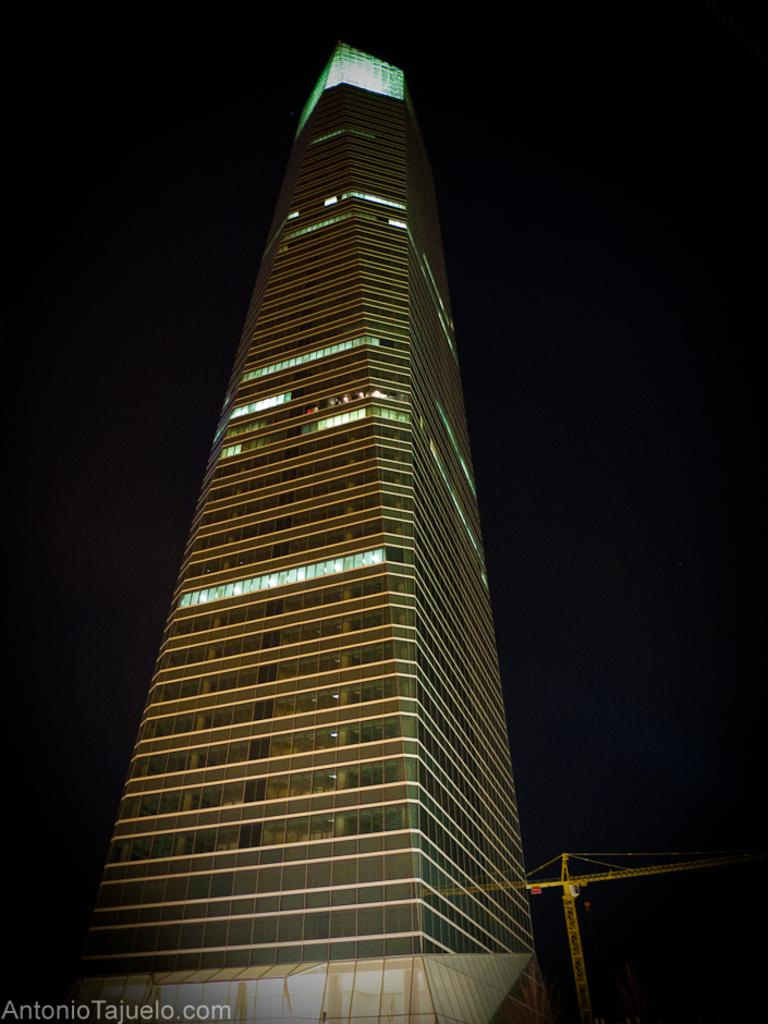What type of structure is depicted in the image? There is a tall building in the image. Are there any specific features of the building that can be observed? Yes, there are lights at the top of the building. What type of pipe can be seen connecting the building to the ground in the image? There is no pipe connecting the building to the ground in the image. What hour of the day is depicted in the image? The provided facts do not give any information about the time of day, so it cannot be determined from the image. 